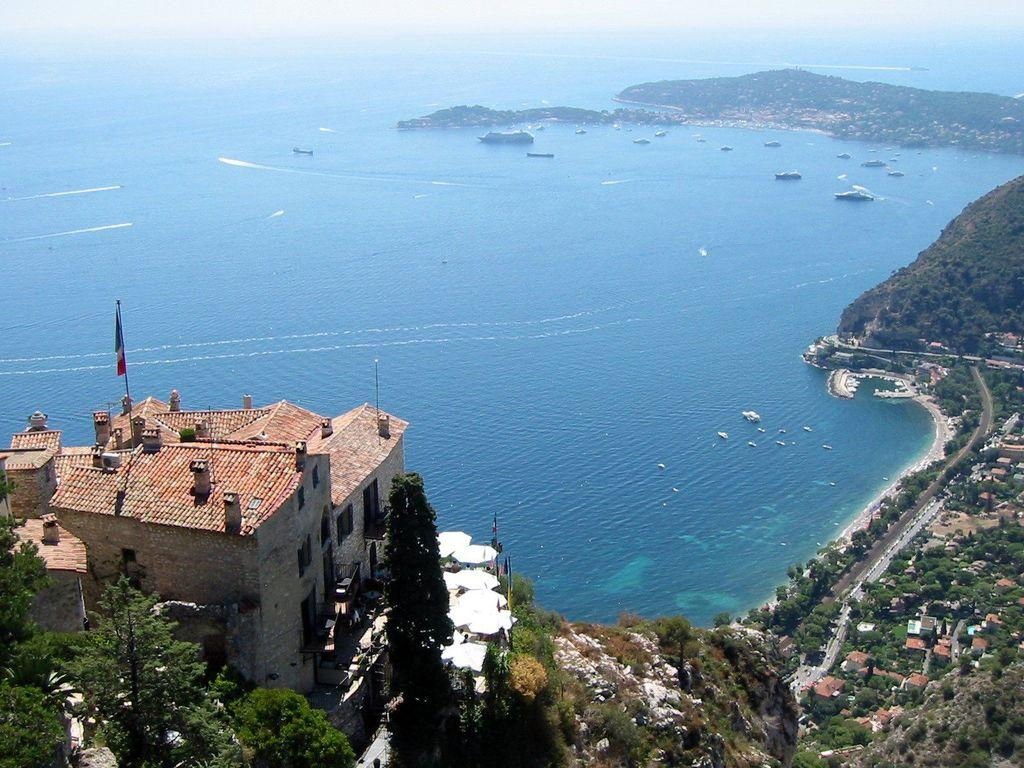What type of structures can be seen in the image? There are buildings in the image. What type of natural elements are present in the image? There are trees and water visible in the image. What is the symbolic object in the image? There is a flag in the image. What type of geographical feature is visible in the image? There are hills in the image. What type of act is the cup performing in the image? There is no cup present in the image, and therefore no such act can be observed. What type of crib is visible in the image? There is no crib present in the image. 